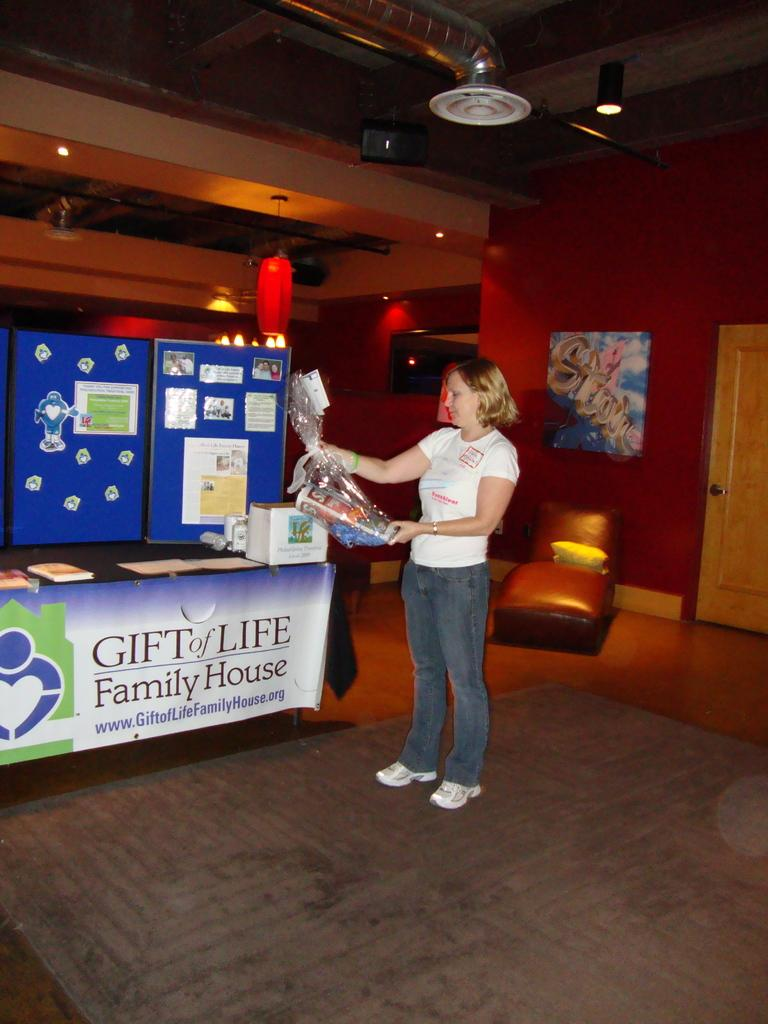What is the main subject of the image? There is a woman standing in the image. What is the woman wearing? The woman is wearing a white t-shirt. What can be seen on the left side of the image? There are machines in the left side of the image. What color are the machines? The machines are blue in color. What is visible at the top of the image? There is a light at the top of the image. What type of harmony is being played by the women in the image? There are no women playing any harmony in the image; it only features a woman standing and machines. What kind of pest can be seen crawling on the machines in the image? There are no pests visible on the machines in the image; only the woman and the machines are present. 